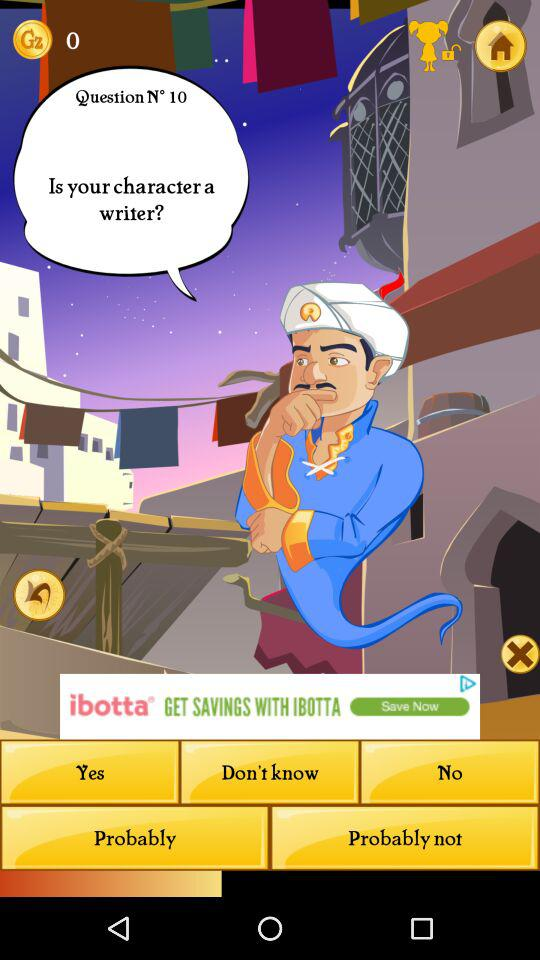Which response option is selected?
When the provided information is insufficient, respond with <no answer>. <no answer> 